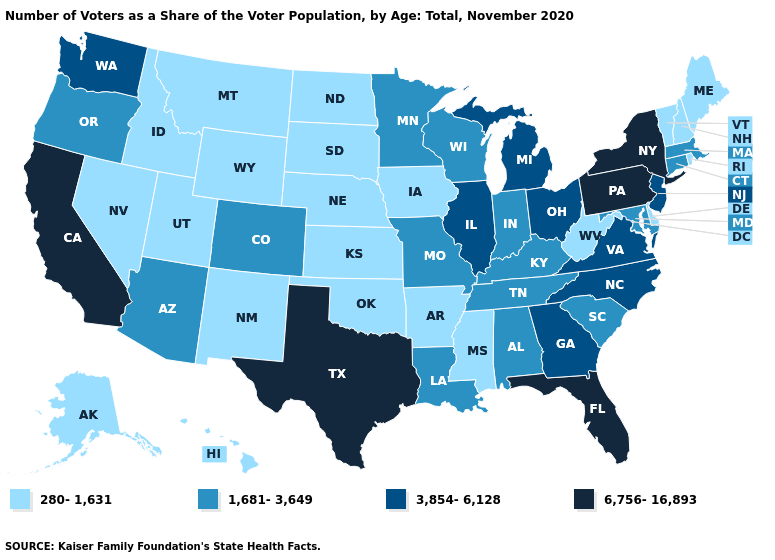Name the states that have a value in the range 3,854-6,128?
Concise answer only. Georgia, Illinois, Michigan, New Jersey, North Carolina, Ohio, Virginia, Washington. Name the states that have a value in the range 1,681-3,649?
Short answer required. Alabama, Arizona, Colorado, Connecticut, Indiana, Kentucky, Louisiana, Maryland, Massachusetts, Minnesota, Missouri, Oregon, South Carolina, Tennessee, Wisconsin. Does Utah have the lowest value in the USA?
Give a very brief answer. Yes. Name the states that have a value in the range 1,681-3,649?
Keep it brief. Alabama, Arizona, Colorado, Connecticut, Indiana, Kentucky, Louisiana, Maryland, Massachusetts, Minnesota, Missouri, Oregon, South Carolina, Tennessee, Wisconsin. Among the states that border Minnesota , does Wisconsin have the lowest value?
Quick response, please. No. What is the highest value in the West ?
Be succinct. 6,756-16,893. Which states hav the highest value in the MidWest?
Answer briefly. Illinois, Michigan, Ohio. Among the states that border Iowa , does Illinois have the highest value?
Answer briefly. Yes. Name the states that have a value in the range 1,681-3,649?
Give a very brief answer. Alabama, Arizona, Colorado, Connecticut, Indiana, Kentucky, Louisiana, Maryland, Massachusetts, Minnesota, Missouri, Oregon, South Carolina, Tennessee, Wisconsin. Does Tennessee have the lowest value in the South?
Be succinct. No. Among the states that border North Carolina , which have the highest value?
Quick response, please. Georgia, Virginia. Does South Carolina have the lowest value in the USA?
Write a very short answer. No. What is the value of New Jersey?
Give a very brief answer. 3,854-6,128. What is the value of Washington?
Short answer required. 3,854-6,128. Name the states that have a value in the range 1,681-3,649?
Answer briefly. Alabama, Arizona, Colorado, Connecticut, Indiana, Kentucky, Louisiana, Maryland, Massachusetts, Minnesota, Missouri, Oregon, South Carolina, Tennessee, Wisconsin. 